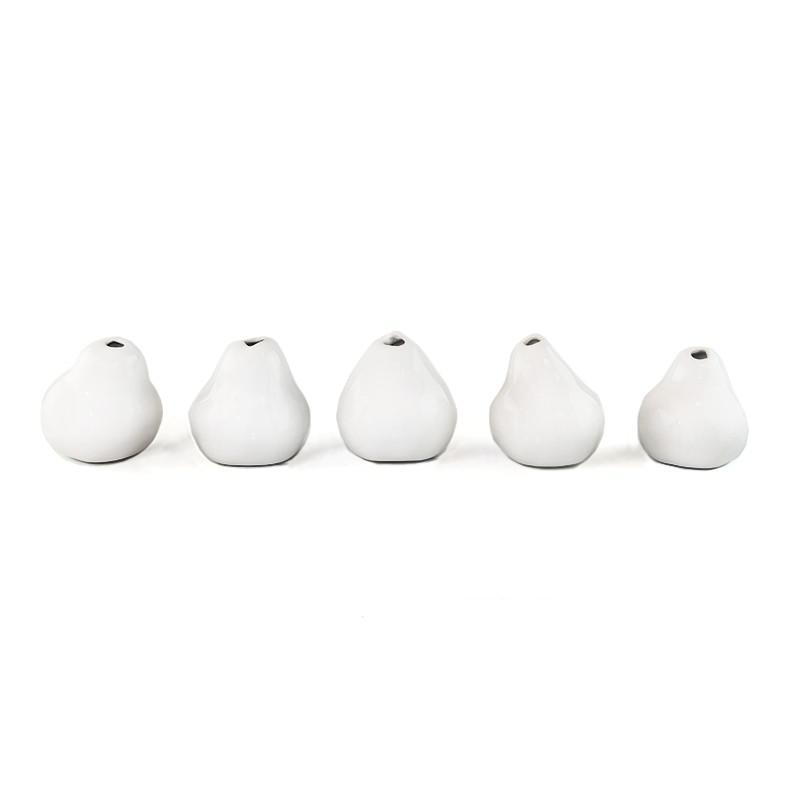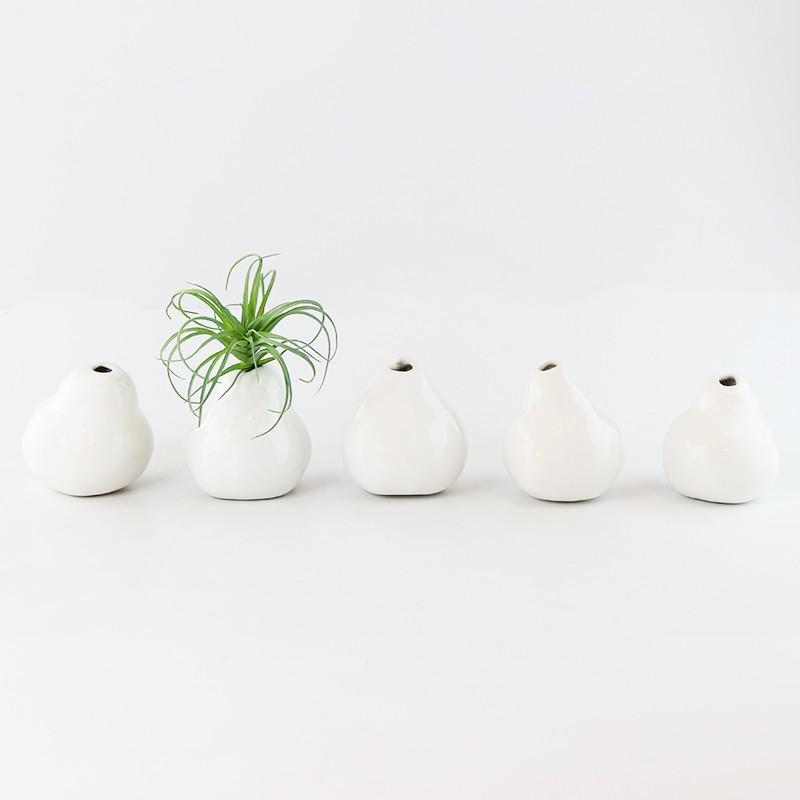The first image is the image on the left, the second image is the image on the right. For the images shown, is this caption "There are 2 pieces of fruit sitting next to a vase." true? Answer yes or no. No. The first image is the image on the left, the second image is the image on the right. For the images shown, is this caption "In the right side image, there is a plant in only one of the vases." true? Answer yes or no. Yes. 